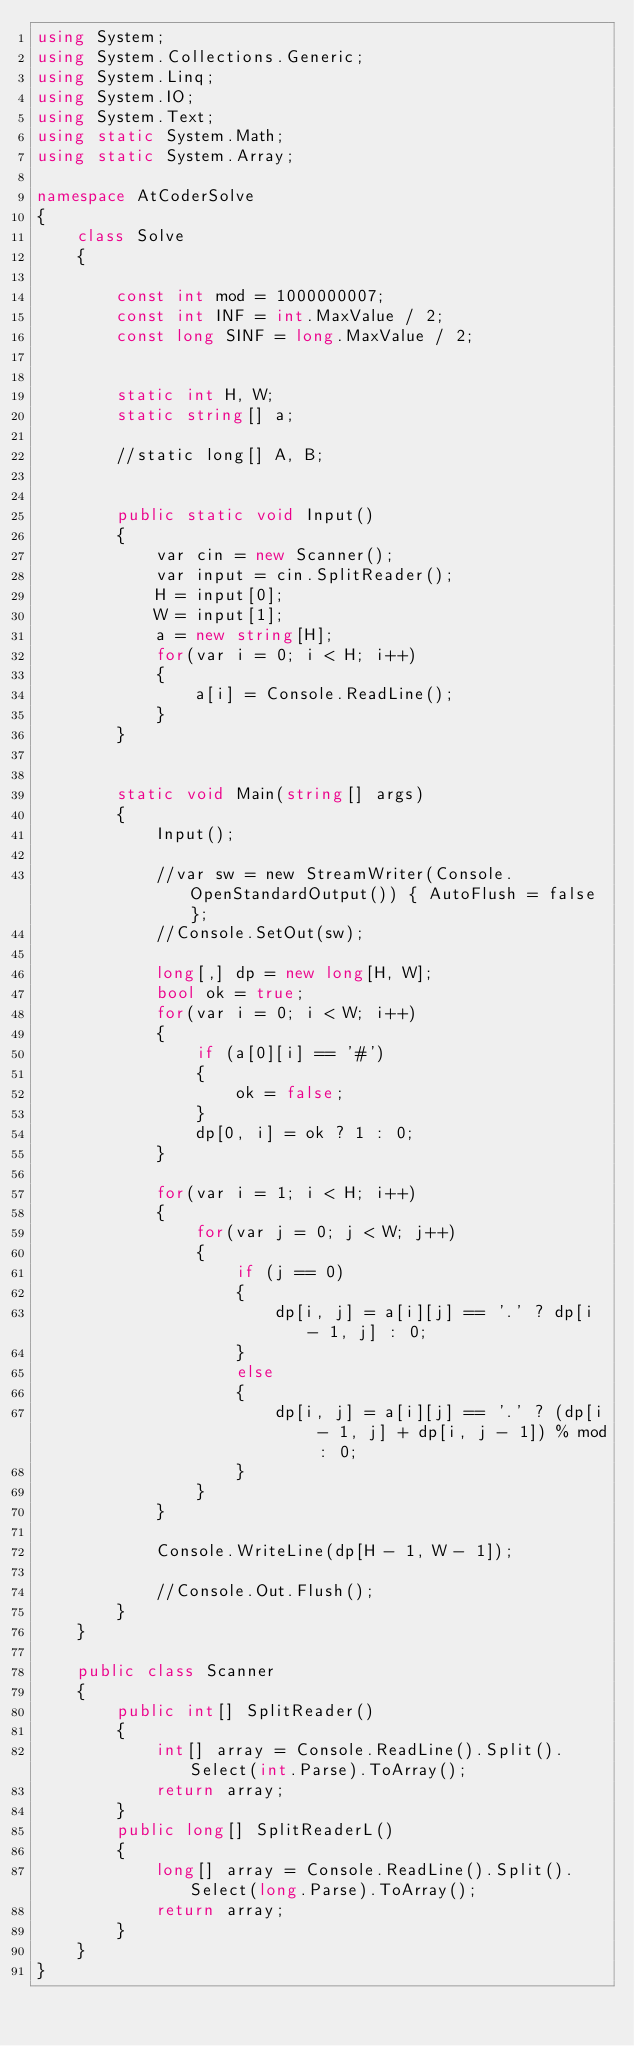<code> <loc_0><loc_0><loc_500><loc_500><_C#_>using System;
using System.Collections.Generic;
using System.Linq;
using System.IO;
using System.Text;
using static System.Math;
using static System.Array;

namespace AtCoderSolve
{
    class Solve
    {

        const int mod = 1000000007;
        const int INF = int.MaxValue / 2;
        const long SINF = long.MaxValue / 2;


        static int H, W;
        static string[] a;
        
        //static long[] A, B;


        public static void Input()
        {
            var cin = new Scanner();
            var input = cin.SplitReader();
            H = input[0];
            W = input[1];
            a = new string[H];
            for(var i = 0; i < H; i++)
            {
                a[i] = Console.ReadLine();
            }
        }


        static void Main(string[] args)
        {
            Input();

            //var sw = new StreamWriter(Console.OpenStandardOutput()) { AutoFlush = false };
            //Console.SetOut(sw);

            long[,] dp = new long[H, W];
            bool ok = true;
            for(var i = 0; i < W; i++)
            {
                if (a[0][i] == '#')
                {
                    ok = false;
                }
                dp[0, i] = ok ? 1 : 0;
            }

            for(var i = 1; i < H; i++)
            {
                for(var j = 0; j < W; j++)
                {
                    if (j == 0)
                    {
                        dp[i, j] = a[i][j] == '.' ? dp[i - 1, j] : 0;
                    }
                    else
                    {
                        dp[i, j] = a[i][j] == '.' ? (dp[i - 1, j] + dp[i, j - 1]) % mod : 0;
                    }
                }
            }

            Console.WriteLine(dp[H - 1, W - 1]);

            //Console.Out.Flush();
        }
    }

    public class Scanner
    {
        public int[] SplitReader()
        {
            int[] array = Console.ReadLine().Split().Select(int.Parse).ToArray();
            return array;
        }
        public long[] SplitReaderL()
        {
            long[] array = Console.ReadLine().Split().Select(long.Parse).ToArray();
            return array;
        }
    }
}




</code> 